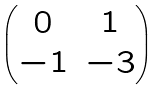<formula> <loc_0><loc_0><loc_500><loc_500>\begin{pmatrix} 0 & 1 \\ - 1 & - 3 \end{pmatrix}</formula> 